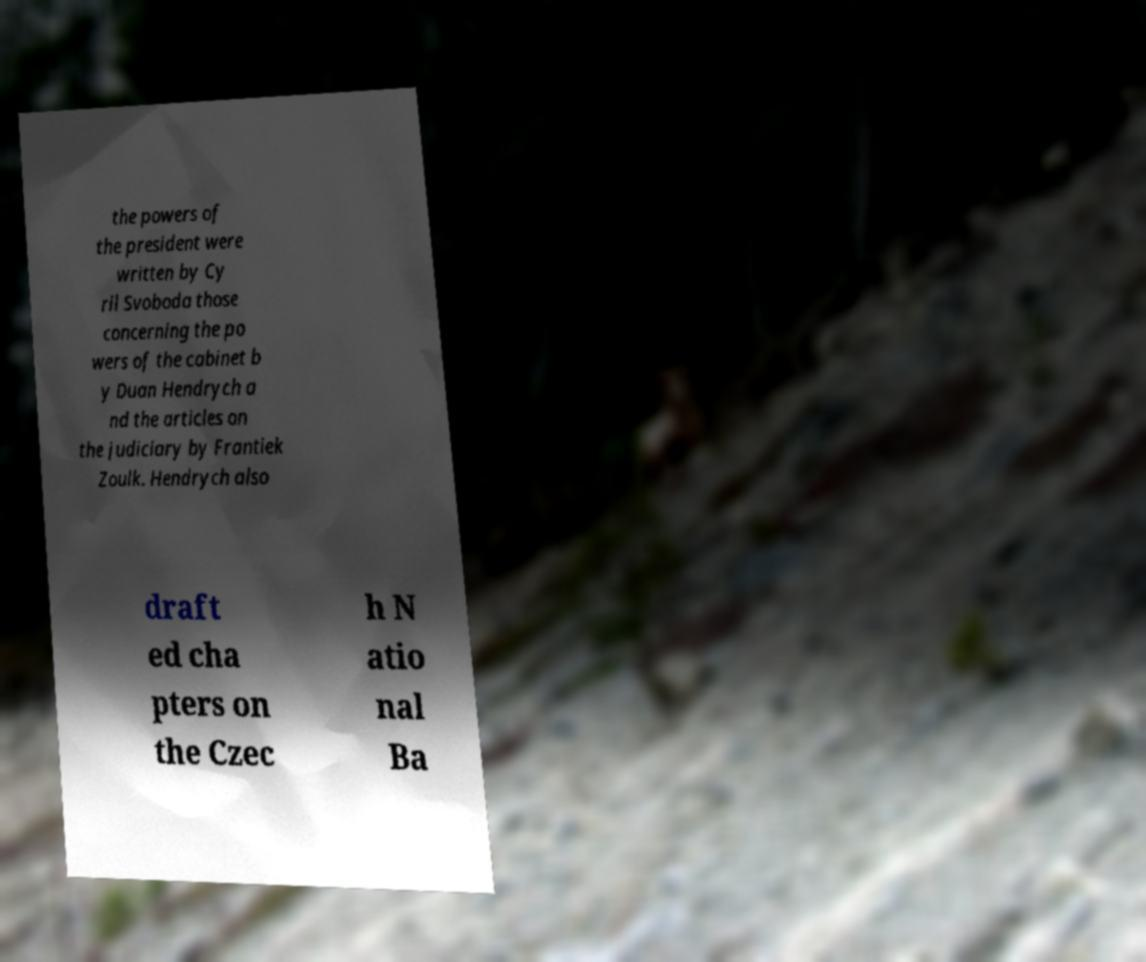There's text embedded in this image that I need extracted. Can you transcribe it verbatim? the powers of the president were written by Cy ril Svoboda those concerning the po wers of the cabinet b y Duan Hendrych a nd the articles on the judiciary by Frantiek Zoulk. Hendrych also draft ed cha pters on the Czec h N atio nal Ba 